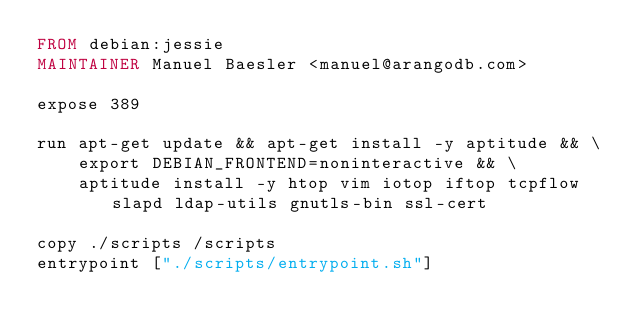<code> <loc_0><loc_0><loc_500><loc_500><_Dockerfile_>FROM debian:jessie
MAINTAINER Manuel Baesler <manuel@arangodb.com>

expose 389

run apt-get update && apt-get install -y aptitude && \
    export DEBIAN_FRONTEND=noninteractive && \
    aptitude install -y htop vim iotop iftop tcpflow slapd ldap-utils gnutls-bin ssl-cert

copy ./scripts /scripts
entrypoint ["./scripts/entrypoint.sh"]
</code> 